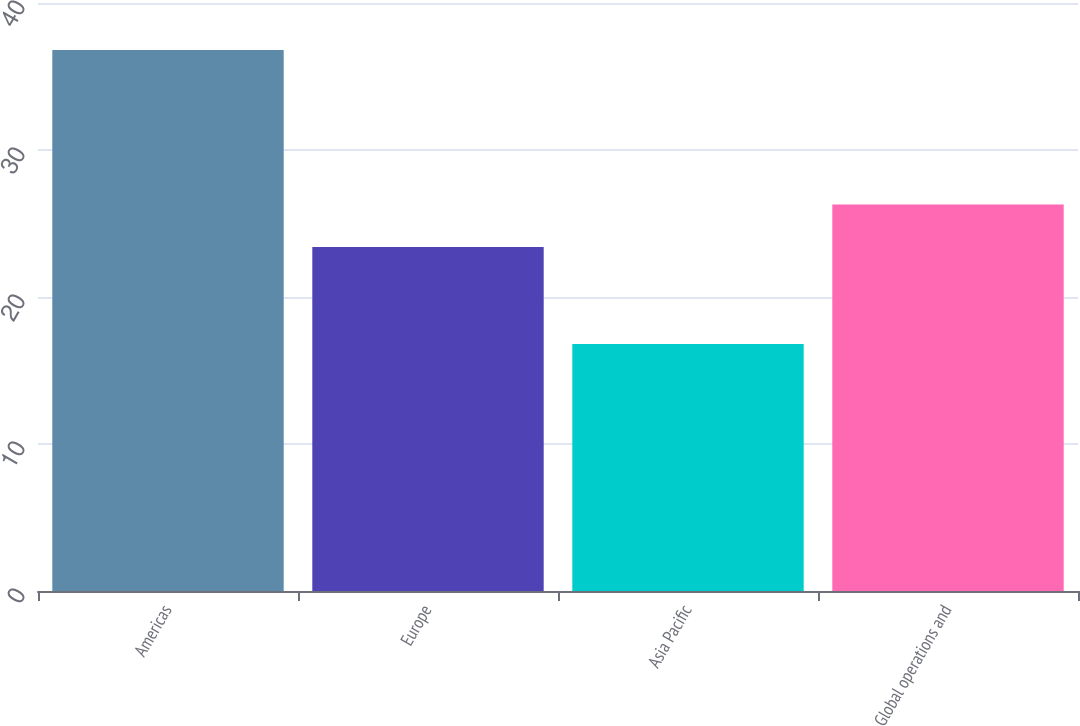Convert chart. <chart><loc_0><loc_0><loc_500><loc_500><bar_chart><fcel>Americas<fcel>Europe<fcel>Asia Pacific<fcel>Global operations and<nl><fcel>36.8<fcel>23.4<fcel>16.8<fcel>26.3<nl></chart> 